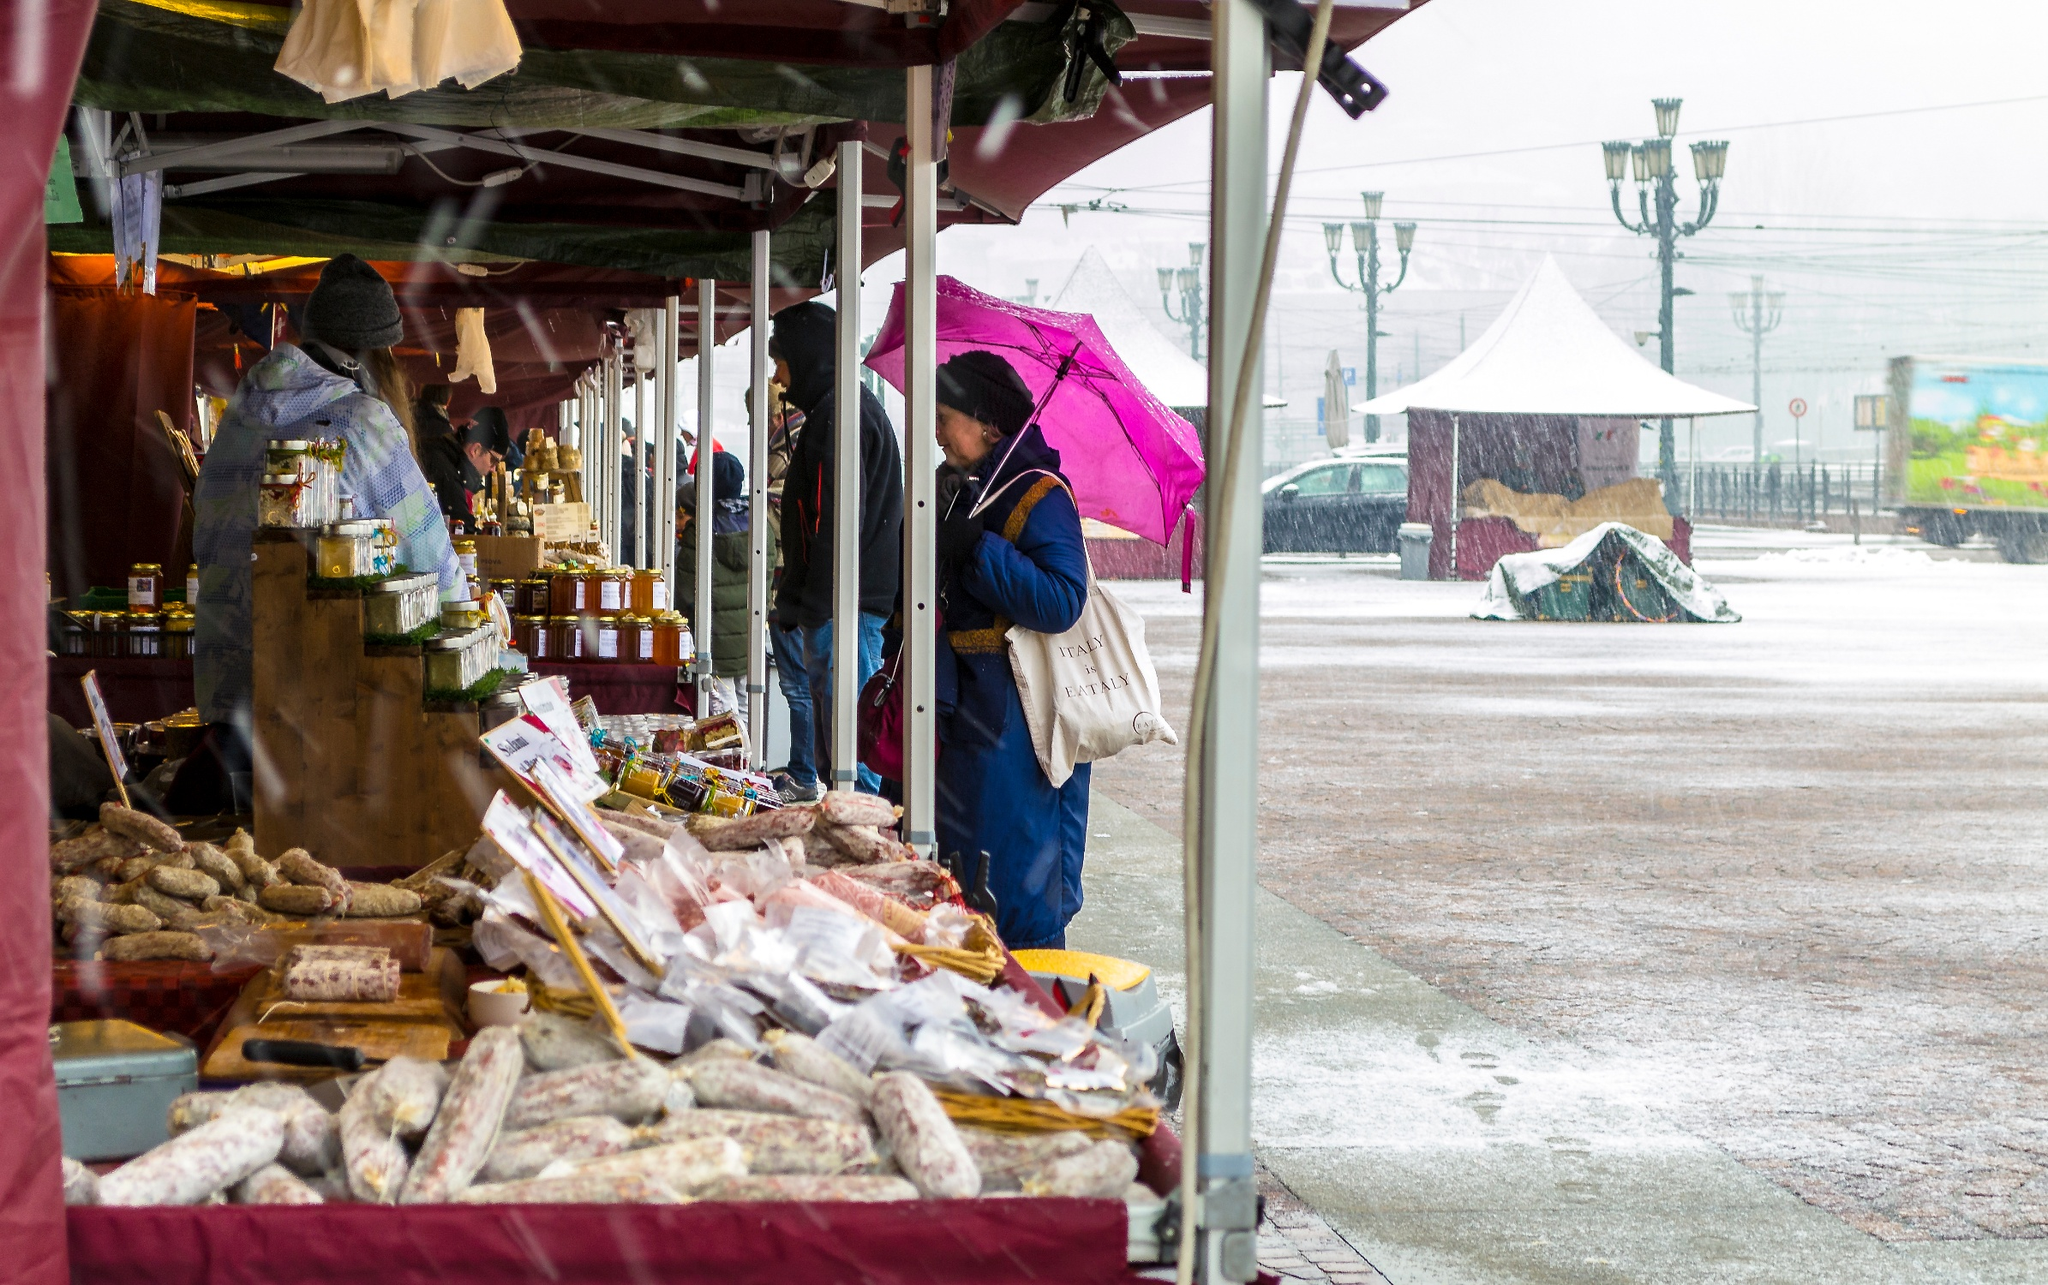Who might be visiting this market, and what are their reasons for being there? This vibrant market might attract a variety of visitors. Local residents could be frequent shoppers, drawn by the convenience and fresh, locally sourced products. Tourists might also visit, seeking to experience the charm and unique cultural elements of the local marketplace. Children might accompany their parents, adding to the bustling atmosphere. Vendors from other stalls might also visit to trade and buy goods for their own needs or to socialize with fellow market traders. The reasons for visiting are as diverse as the attendees — some might come for specific items, others for a leisurely stroll, while some might seek the camaraderie and lively spirit that markets often provide. Could you describe a day in the life of the market vendor? Certainly! A day in the life of the market vendor begins early in the morning. They might start by preparing their products, ensuring everything is fresh and well-organized. By dawn, they head to the marketplace to set up their stall, carefully arranging their goods under the canopy. Throughout the day, they interact with a diverse range of customers, offering sharegpt4v/samples, making sales, and engaging in friendly banter. The vendor must remain attentive, managing stock and handling money while providing excellent customer service. Lunch might be a quick bite behind the stall or a shared meal with a neighboring vendor. As the day draws to a close, they count their earnings, pack up their stall, and possibly think about the next market day, reflecting on the day's events. This routine fosters a strong sense of community and dedication. If you could imagine an interaction between a vendor and a customer about the secret recipe of their goods, how would it go? Customer: 'Your sausages are absolutely delicious! I've never tasted anything quite like them. What's your secret?' 

Vendor, with a smile: 'Ah, well, a good recipe always has its secrets, doesn't it? But I can tell you it involves a blend of traditional herbs and spices passed down through generations in my family.' 

Customer: 'I see, so it's a family recipe then?' 

Vendor: 'Indeed it is! My great-grandmother started making these when she was just a young girl, and we've perfected it over the years. It’s all about the quality of ingredients and a little bit of love and care in the preparation.' 

Customer: 'Well, whatever it is, it works perfectly. I'll take a dozen!' 

Vendor: 'Coming right up! And thank you for your kind words. Enjoy!' 